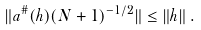<formula> <loc_0><loc_0><loc_500><loc_500>\| a ^ { \# } ( h ) ( N + 1 ) ^ { - 1 / 2 } \| \leq \| h \| \, .</formula> 